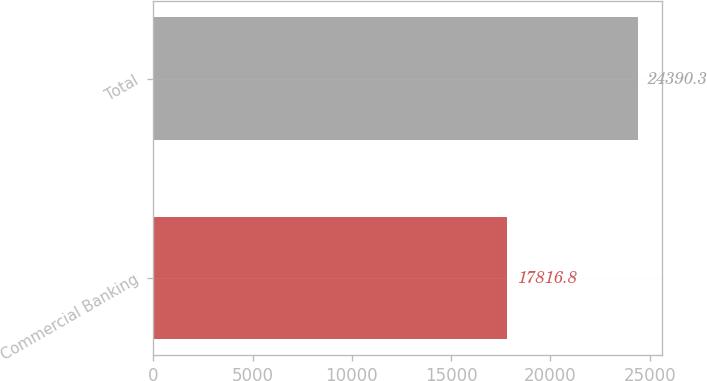<chart> <loc_0><loc_0><loc_500><loc_500><bar_chart><fcel>Commercial Banking<fcel>Total<nl><fcel>17816.8<fcel>24390.3<nl></chart> 